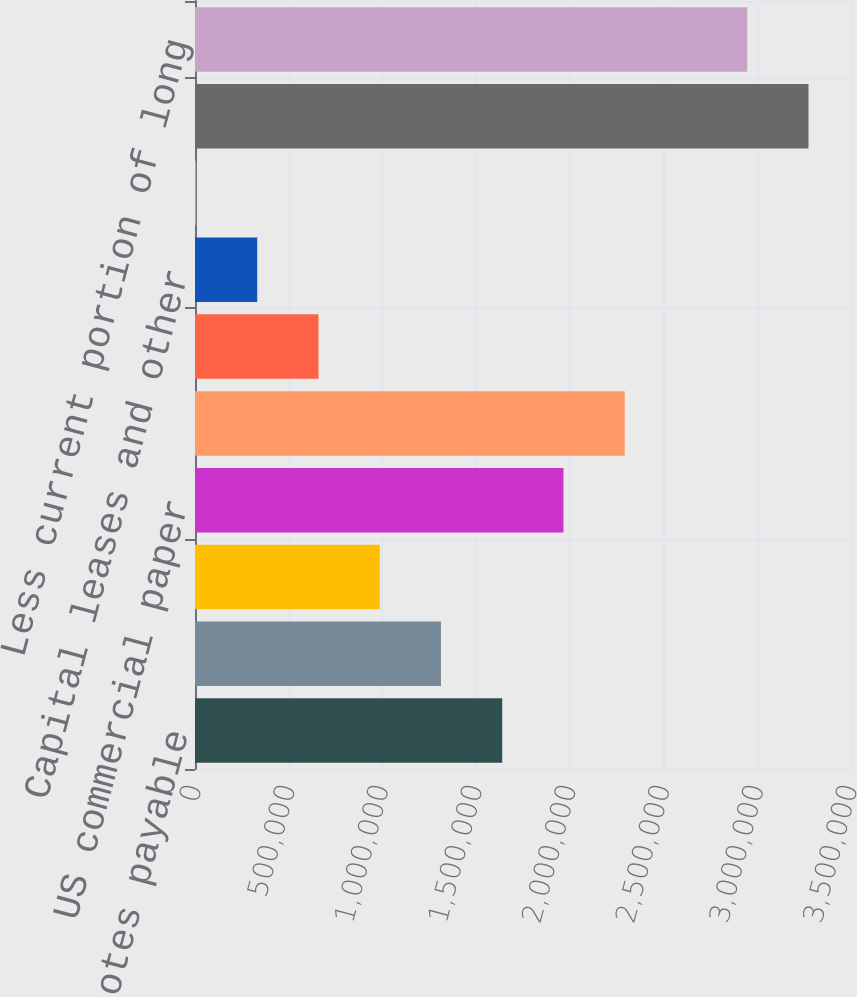Convert chart to OTSL. <chart><loc_0><loc_0><loc_500><loc_500><bar_chart><fcel>385 senior notes payable<fcel>200 senior notes payable<fcel>Floating Rate Notes payable<fcel>US commercial paper<fcel>European commercial paper<fcel>Five-year senior secured<fcel>Capital leases and other<fcel>Unamortized debt issuance<fcel>Total debt<fcel>Less current portion of long<nl><fcel>1.63918e+06<fcel>1.31237e+06<fcel>985569<fcel>1.96598e+06<fcel>2.29279e+06<fcel>658765<fcel>331960<fcel>5155<fcel>3.2732e+06<fcel>2.9464e+06<nl></chart> 